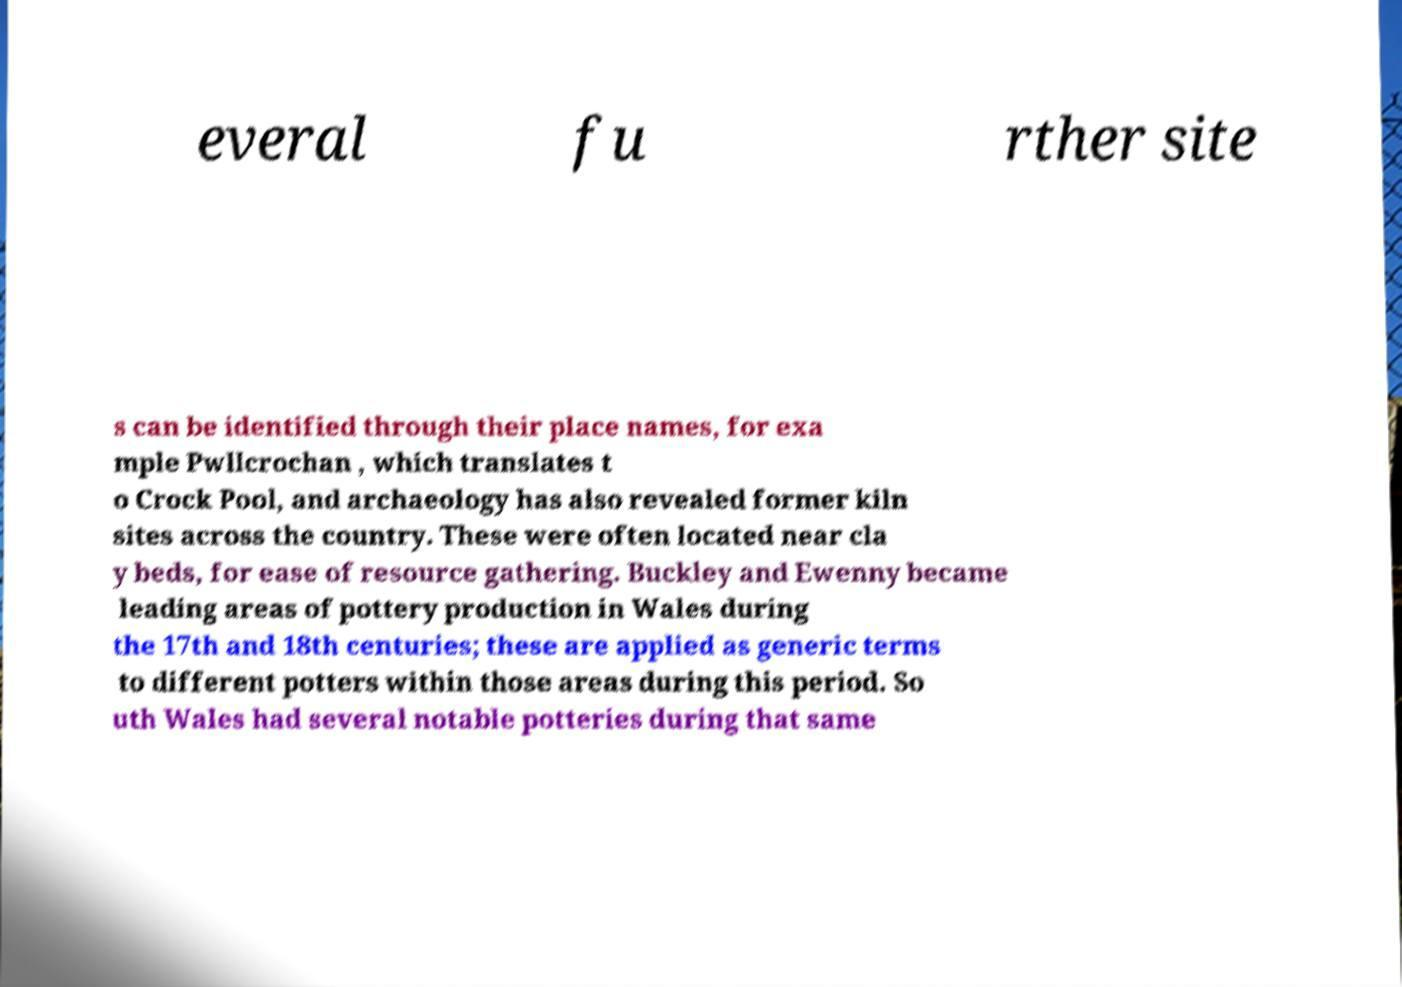Could you extract and type out the text from this image? everal fu rther site s can be identified through their place names, for exa mple Pwllcrochan , which translates t o Crock Pool, and archaeology has also revealed former kiln sites across the country. These were often located near cla y beds, for ease of resource gathering. Buckley and Ewenny became leading areas of pottery production in Wales during the 17th and 18th centuries; these are applied as generic terms to different potters within those areas during this period. So uth Wales had several notable potteries during that same 